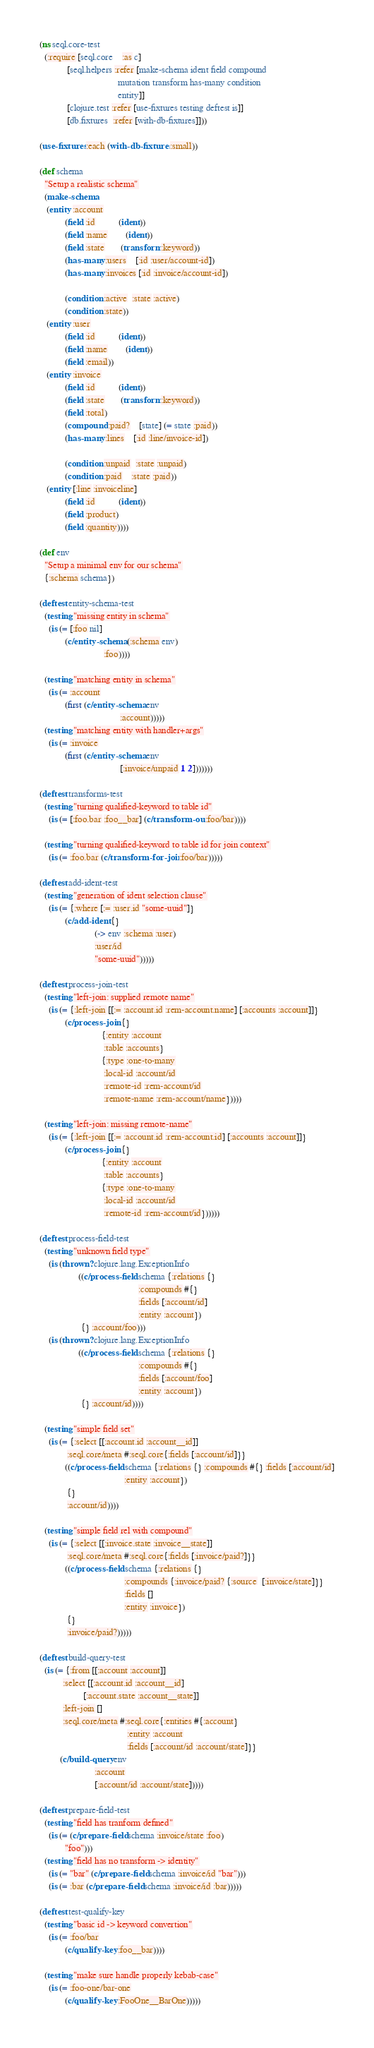Convert code to text. <code><loc_0><loc_0><loc_500><loc_500><_Clojure_>(ns seql.core-test
  (:require [seql.core    :as c]
            [seql.helpers :refer [make-schema ident field compound
                                  mutation transform has-many condition
                                  entity]]
            [clojure.test :refer [use-fixtures testing deftest is]]
            [db.fixtures  :refer [with-db-fixtures]]))

(use-fixtures :each (with-db-fixtures :small))

(def schema
  "Setup a realistic schema"
  (make-schema
   (entity :account
           (field :id          (ident))
           (field :name        (ident))
           (field :state       (transform :keyword))
           (has-many :users    [:id :user/account-id])
           (has-many :invoices [:id :invoice/account-id])

           (condition :active  :state :active)
           (condition :state))
   (entity :user
           (field :id          (ident))
           (field :name        (ident))
           (field :email))
   (entity :invoice
           (field :id          (ident))
           (field :state       (transform :keyword))
           (field :total)
           (compound :paid?    [state] (= state :paid))
           (has-many :lines    [:id :line/invoice-id])

           (condition :unpaid  :state :unpaid)
           (condition :paid    :state :paid))
   (entity [:line :invoiceline]
           (field :id          (ident))
           (field :product)
           (field :quantity))))

(def env
  "Setup a minimal env for our schema"
  {:schema schema})

(deftest entity-schema-test
  (testing "missing entity in schema"
    (is (= [:foo nil]
           (c/entity-schema (:schema env)
                            :foo))))

  (testing "matching entity in schema"
    (is (= :account
           (first (c/entity-schema env
                                   :account)))))
  (testing "matching entity with handler+args"
    (is (= :invoice
           (first (c/entity-schema env
                                   [:invoice/unpaid 1 2]))))))

(deftest transforms-test
  (testing "turning qualified-keyword to table id"
    (is (= [:foo.bar :foo__bar] (c/transform-out :foo/bar))))

  (testing "turning qualified-keyword to table id for join context"
    (is (= :foo.bar (c/transform-for-join :foo/bar)))))

(deftest add-ident-test
  (testing "generation of ident selection clause"
    (is (= {:where [:= :user.id "some-uuid"]}
           (c/add-ident {}
                        (-> env :schema :user)
                        :user/id
                        "some-uuid")))))

(deftest process-join-test
  (testing "left-join: supplied remote name"
    (is (= {:left-join [[:= :account.id :rem-account.name] [:accounts :account]]}
           (c/process-join {}
                           {:entity :account
                            :table :accounts}
                           {:type :one-to-many
                            :local-id :account/id
                            :remote-id :rem-account/id
                            :remote-name :rem-account/name}))))

  (testing "left-join: missing remote-name"
    (is (= {:left-join [[:= :account.id :rem-account.id] [:accounts :account]]}
           (c/process-join {}
                           {:entity :account
                            :table :accounts}
                           {:type :one-to-many
                            :local-id :account/id
                            :remote-id :rem-account/id})))))

(deftest process-field-test
  (testing "unknown field type"
    (is (thrown? clojure.lang.ExceptionInfo
                 ((c/process-field schema {:relations {}
                                           :compounds #{}
                                           :fields [:account/id]
                                           :entity :account})
                  {} :account/foo)))
    (is (thrown? clojure.lang.ExceptionInfo
                 ((c/process-field schema {:relations {}
                                           :compounds #{}
                                           :fields [:account/foo]
                                           :entity :account})
                  {} :account/id))))

  (testing "simple field set"
    (is (= {:select [[:account.id :account__id]]
            :seql.core/meta #:seql.core{:fields [:account/id]}}
           ((c/process-field schema {:relations {} :compounds #{} :fields [:account/id]
                                     :entity :account})
            {}
            :account/id))))

  (testing "simple field rel with compound"
    (is (= {:select [[:invoice.state :invoice__state]]
            :seql.core/meta #:seql.core{:fields [:invoice/paid?]}}
           ((c/process-field schema {:relations {}
                                     :compounds {:invoice/paid? {:source  [:invoice/state]}}
                                     :fields []
                                     :entity :invoice})
            {}
            :invoice/paid?)))))

(deftest build-query-test
  (is (= {:from [[:account :account]]
          :select [[:account.id :account__id]
                   [:account.state :account__state]]
          :left-join []
          :seql.core/meta #:seql.core{:entities #{:account}
                                      :entity :account
                                      :fields [:account/id :account/state]}}
         (c/build-query env
                        :account
                        [:account/id :account/state]))))

(deftest prepare-field-test
  (testing "field has tranform defined"
    (is (= (c/prepare-field schema :invoice/state :foo)
           "foo")))
  (testing "field has no transform -> identity"
    (is (= "bar" (c/prepare-field schema :invoice/id "bar")))
    (is (= :bar (c/prepare-field schema :invoice/id :bar)))))

(deftest test-qualify-key
  (testing "basic id -> keyword convertion"
    (is (= :foo/bar
           (c/qualify-key :foo__bar))))

  (testing "make sure handle properly kebab-case"
    (is (= :foo-one/bar-one
           (c/qualify-key :FooOne__BarOne)))))
</code> 